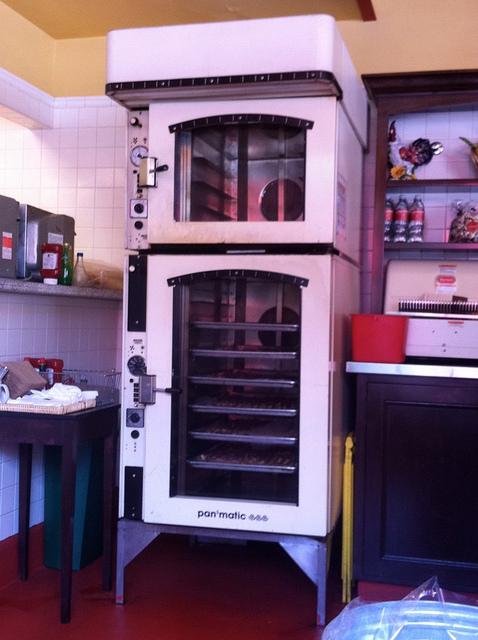Is this an oven?
Quick response, please. Yes. What color is the floor?
Concise answer only. Red. Is the large item used for cooking?
Write a very short answer. Yes. 